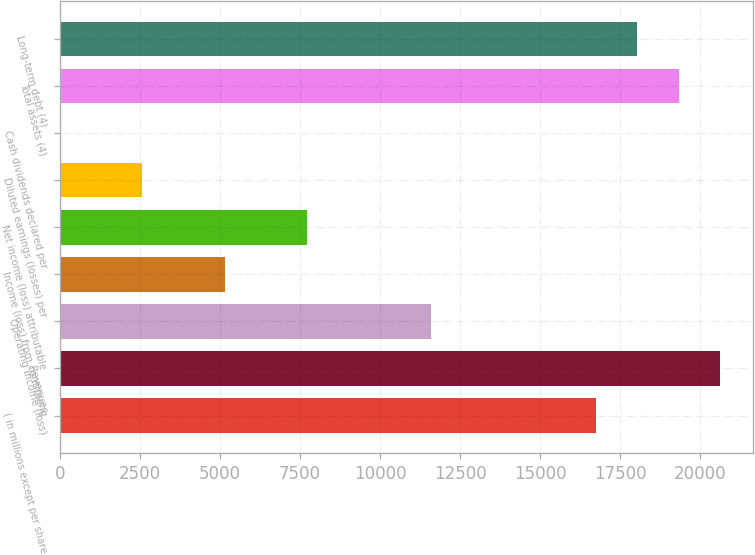Convert chart to OTSL. <chart><loc_0><loc_0><loc_500><loc_500><bar_chart><fcel>( in millions except per share<fcel>Revenues<fcel>Operating income (loss)<fcel>Income (loss) from continuing<fcel>Net income (loss) attributable<fcel>Diluted earnings (losses) per<fcel>Cash dividends declared per<fcel>Total assets (4)<fcel>Long-term debt (4)<nl><fcel>16742.6<fcel>20606.2<fcel>11591.2<fcel>5151.81<fcel>7727.55<fcel>2576.07<fcel>0.33<fcel>19318.4<fcel>18030.5<nl></chart> 